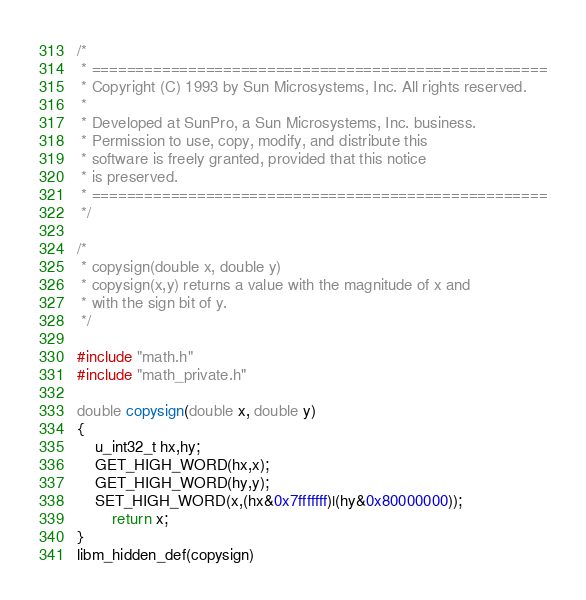Convert code to text. <code><loc_0><loc_0><loc_500><loc_500><_C_>/*
 * ====================================================
 * Copyright (C) 1993 by Sun Microsystems, Inc. All rights reserved.
 *
 * Developed at SunPro, a Sun Microsystems, Inc. business.
 * Permission to use, copy, modify, and distribute this
 * software is freely granted, provided that this notice
 * is preserved.
 * ====================================================
 */

/*
 * copysign(double x, double y)
 * copysign(x,y) returns a value with the magnitude of x and
 * with the sign bit of y.
 */

#include "math.h"
#include "math_private.h"

double copysign(double x, double y)
{
	u_int32_t hx,hy;
	GET_HIGH_WORD(hx,x);
	GET_HIGH_WORD(hy,y);
	SET_HIGH_WORD(x,(hx&0x7fffffff)|(hy&0x80000000));
        return x;
}
libm_hidden_def(copysign)
</code> 